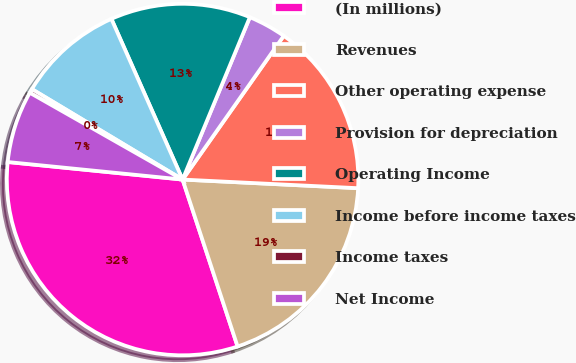Convert chart. <chart><loc_0><loc_0><loc_500><loc_500><pie_chart><fcel>(In millions)<fcel>Revenues<fcel>Other operating expense<fcel>Provision for depreciation<fcel>Operating Income<fcel>Income before income taxes<fcel>Income taxes<fcel>Net Income<nl><fcel>31.66%<fcel>19.15%<fcel>16.02%<fcel>3.51%<fcel>12.89%<fcel>9.76%<fcel>0.38%<fcel>6.63%<nl></chart> 